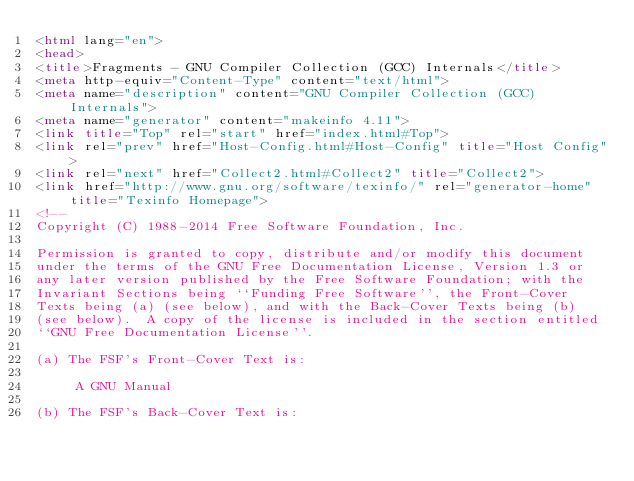Convert code to text. <code><loc_0><loc_0><loc_500><loc_500><_HTML_><html lang="en">
<head>
<title>Fragments - GNU Compiler Collection (GCC) Internals</title>
<meta http-equiv="Content-Type" content="text/html">
<meta name="description" content="GNU Compiler Collection (GCC) Internals">
<meta name="generator" content="makeinfo 4.11">
<link title="Top" rel="start" href="index.html#Top">
<link rel="prev" href="Host-Config.html#Host-Config" title="Host Config">
<link rel="next" href="Collect2.html#Collect2" title="Collect2">
<link href="http://www.gnu.org/software/texinfo/" rel="generator-home" title="Texinfo Homepage">
<!--
Copyright (C) 1988-2014 Free Software Foundation, Inc.

Permission is granted to copy, distribute and/or modify this document
under the terms of the GNU Free Documentation License, Version 1.3 or
any later version published by the Free Software Foundation; with the
Invariant Sections being ``Funding Free Software'', the Front-Cover
Texts being (a) (see below), and with the Back-Cover Texts being (b)
(see below).  A copy of the license is included in the section entitled
``GNU Free Documentation License''.

(a) The FSF's Front-Cover Text is:

     A GNU Manual

(b) The FSF's Back-Cover Text is:
</code> 